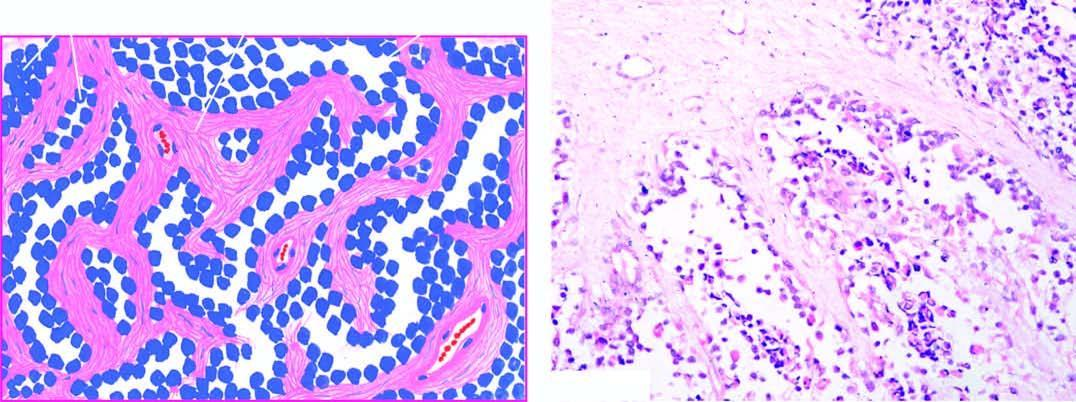re these cases also present?
Answer the question using a single word or phrase. No 